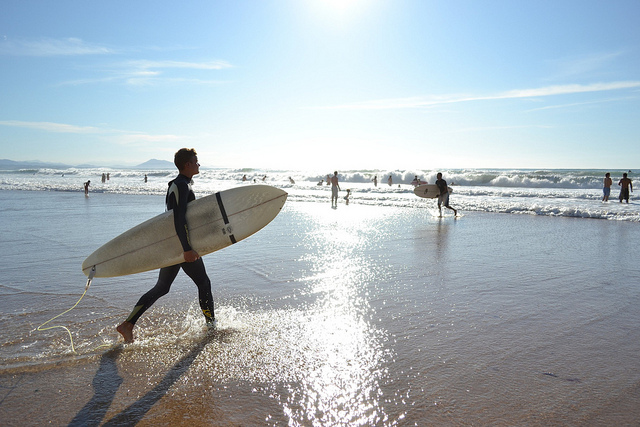What activity is the person in the image doing? The person in the image appears to be a surfer, holding a surfboard and walking along the shore, possibly heading towards or returning from the waves.  Can you tell me more about the surroundings? Certainly, the image shows a sunny beach scene with several people engaging in various activities. Some are wading through the water, others are surfing the waves, and there are individuals walking along the shore. The sky is clear, suggesting favorable weather for beachgoers and surfers alike. 